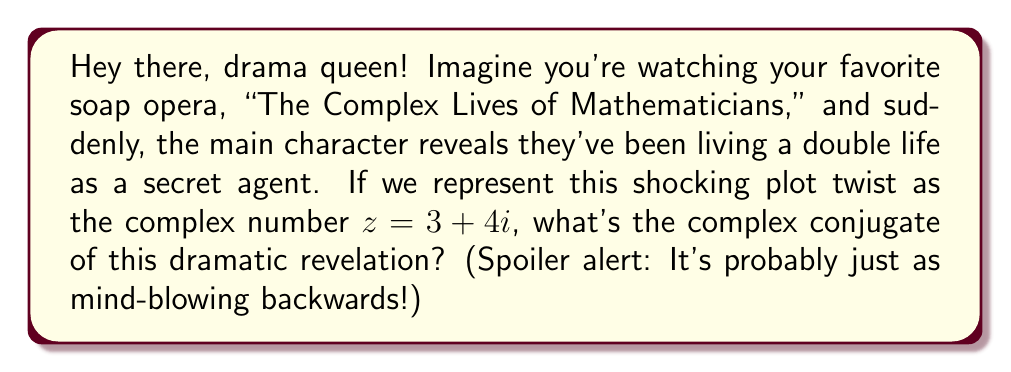Show me your answer to this math problem. Alright, let's break this down for all you mathematic method actors out there:

1) First, let's recall what a complex conjugate is. For a complex number $z = a + bi$, its conjugate is $\overline{z} = a - bi$. It's like the evil twin of our original number, but with a negative attitude towards $i$.

2) In our dramatic scenario, we have $z = 3 + 4i$. This means:
   $a = 3$ (the real part, as real as reality TV)
   $b = 4$ (the imaginary part, like the imaginary friend you had in high school)

3) To find the conjugate, we keep the real part the same and flip the sign of the imaginary part:

   $\overline{z} = 3 - 4i$

4) And there you have it! The complex conjugate of our dramatic plot twist. It's like watching the episode in reverse, but the shock value remains the same!

Remember, in the world of complex numbers, conjugates are like mirror images. They reflect the same drama, just from a slightly different angle. It's the mathematical equivalent of a twin separated at birth plot twist!
Answer: $\overline{z} = 3 - 4i$ 